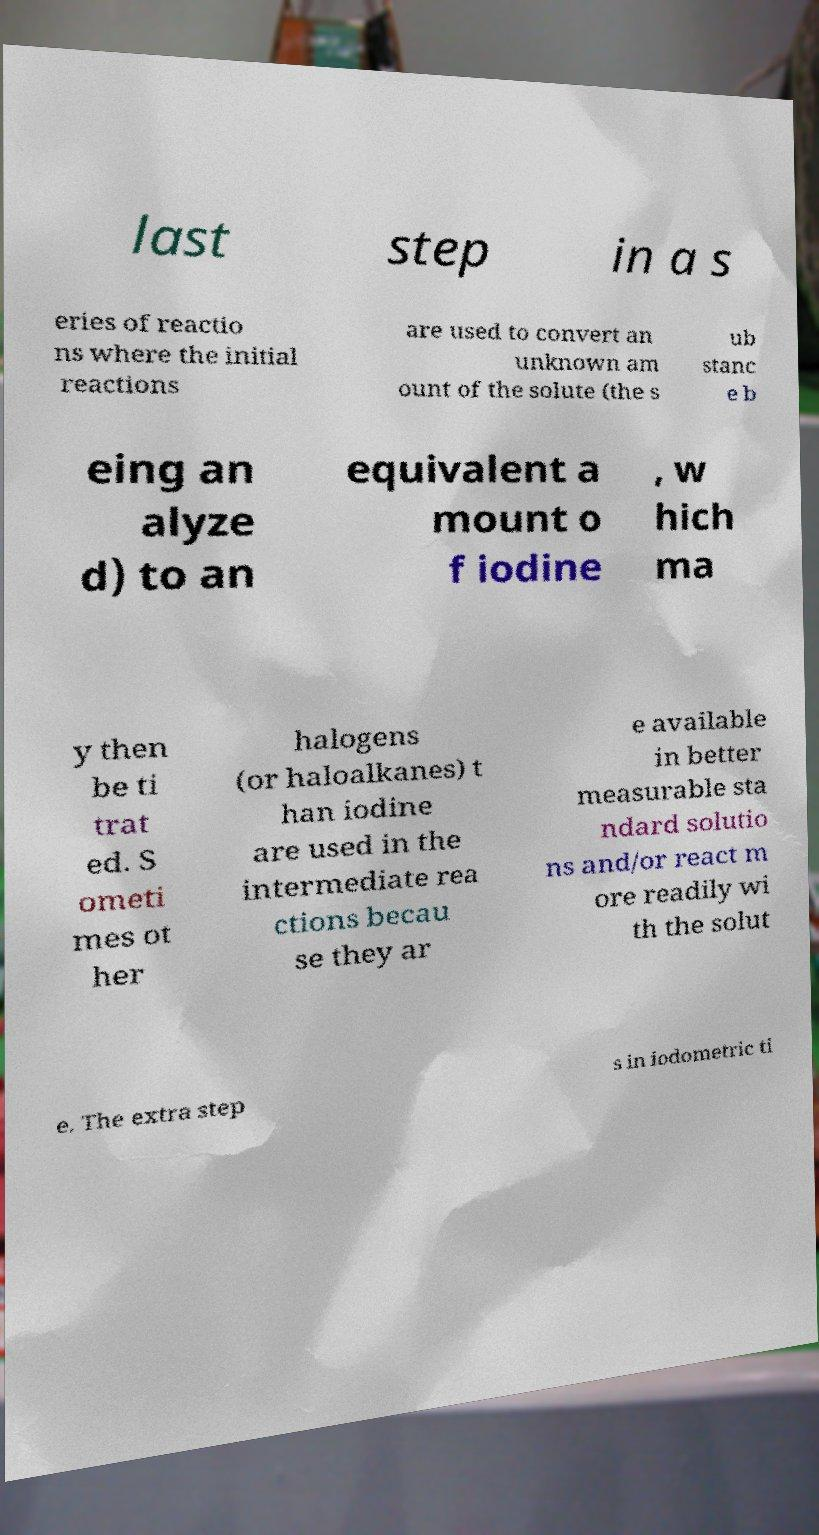Can you accurately transcribe the text from the provided image for me? last step in a s eries of reactio ns where the initial reactions are used to convert an unknown am ount of the solute (the s ub stanc e b eing an alyze d) to an equivalent a mount o f iodine , w hich ma y then be ti trat ed. S ometi mes ot her halogens (or haloalkanes) t han iodine are used in the intermediate rea ctions becau se they ar e available in better measurable sta ndard solutio ns and/or react m ore readily wi th the solut e. The extra step s in iodometric ti 